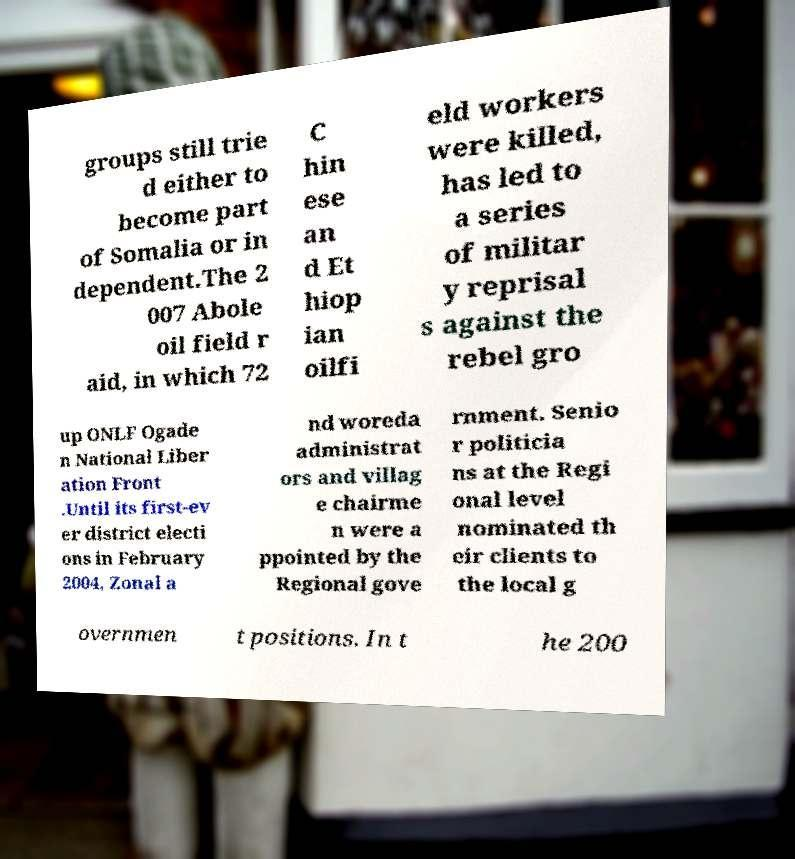Please read and relay the text visible in this image. What does it say? groups still trie d either to become part of Somalia or in dependent.The 2 007 Abole oil field r aid, in which 72 C hin ese an d Et hiop ian oilfi eld workers were killed, has led to a series of militar y reprisal s against the rebel gro up ONLF Ogade n National Liber ation Front .Until its first-ev er district electi ons in February 2004, Zonal a nd woreda administrat ors and villag e chairme n were a ppointed by the Regional gove rnment. Senio r politicia ns at the Regi onal level nominated th eir clients to the local g overnmen t positions. In t he 200 